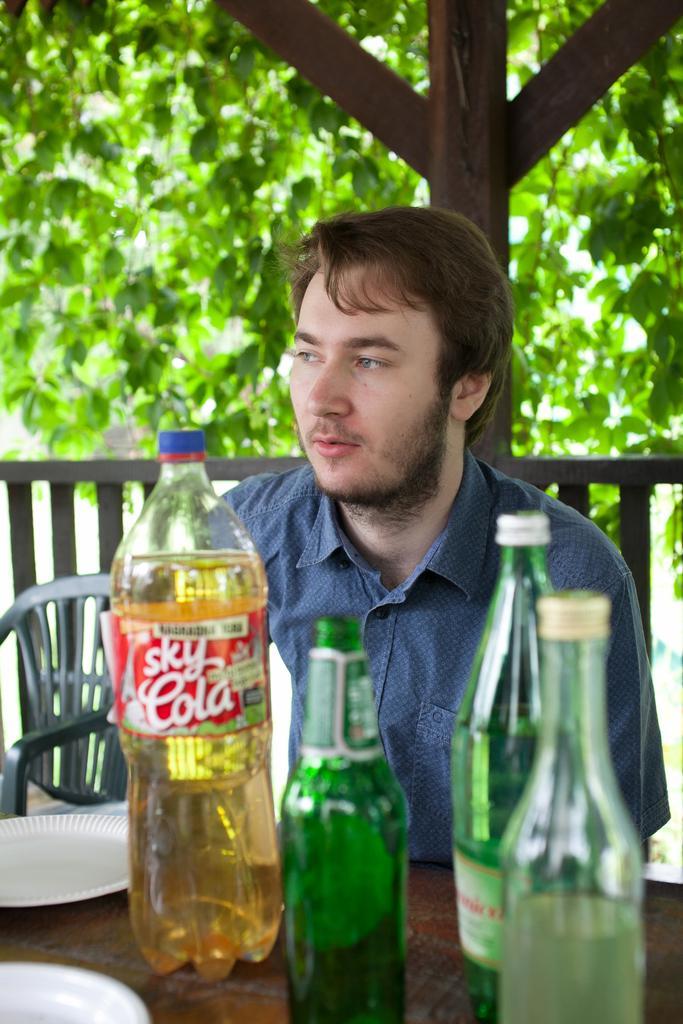Describe this image in one or two sentences. In this picture there is a man sitting on the chair and he has a table in front of him with a beer bottle and a bottle and in the background there are trees. 